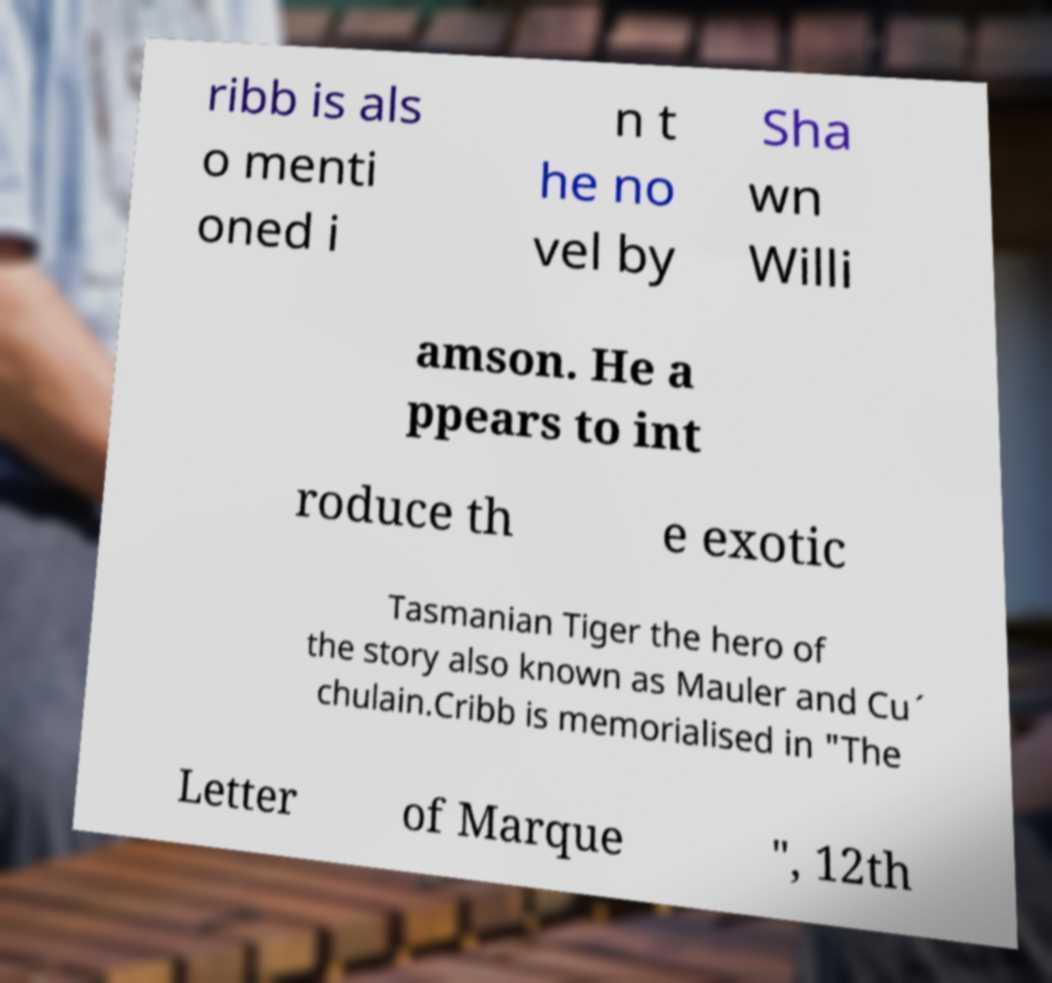There's text embedded in this image that I need extracted. Can you transcribe it verbatim? ribb is als o menti oned i n t he no vel by Sha wn Willi amson. He a ppears to int roduce th e exotic Tasmanian Tiger the hero of the story also known as Mauler and Cu´ chulain.Cribb is memorialised in "The Letter of Marque ", 12th 